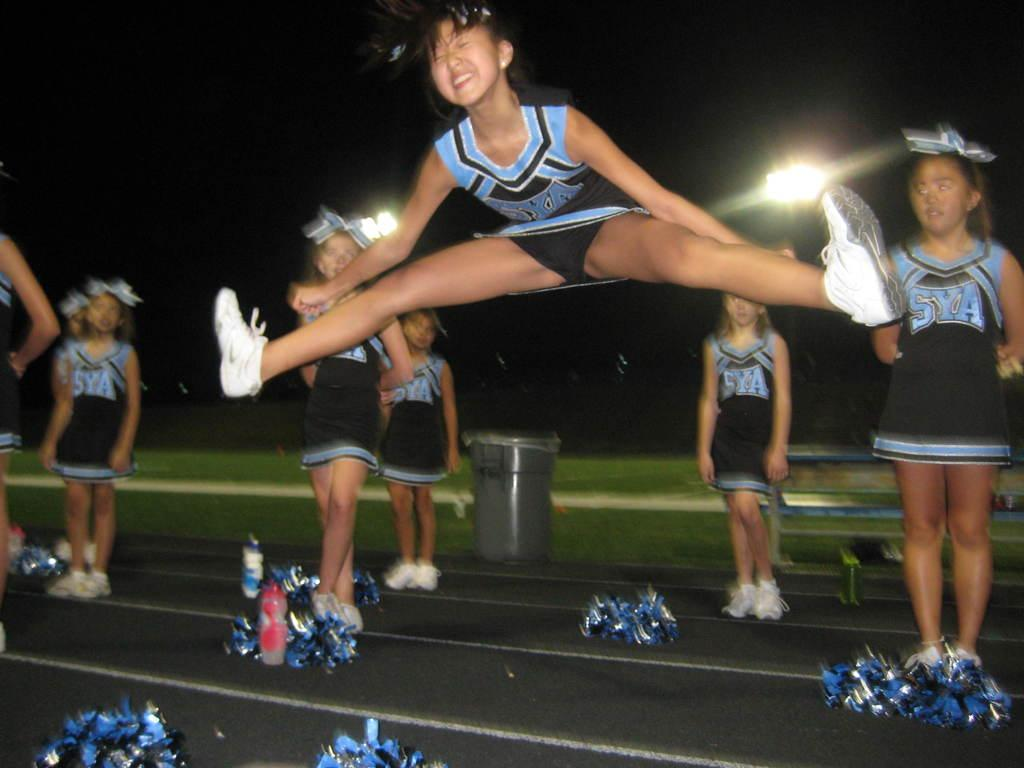<image>
Give a short and clear explanation of the subsequent image. Cheerleaders with SYA on their uniforms watch one perform splits in the air 